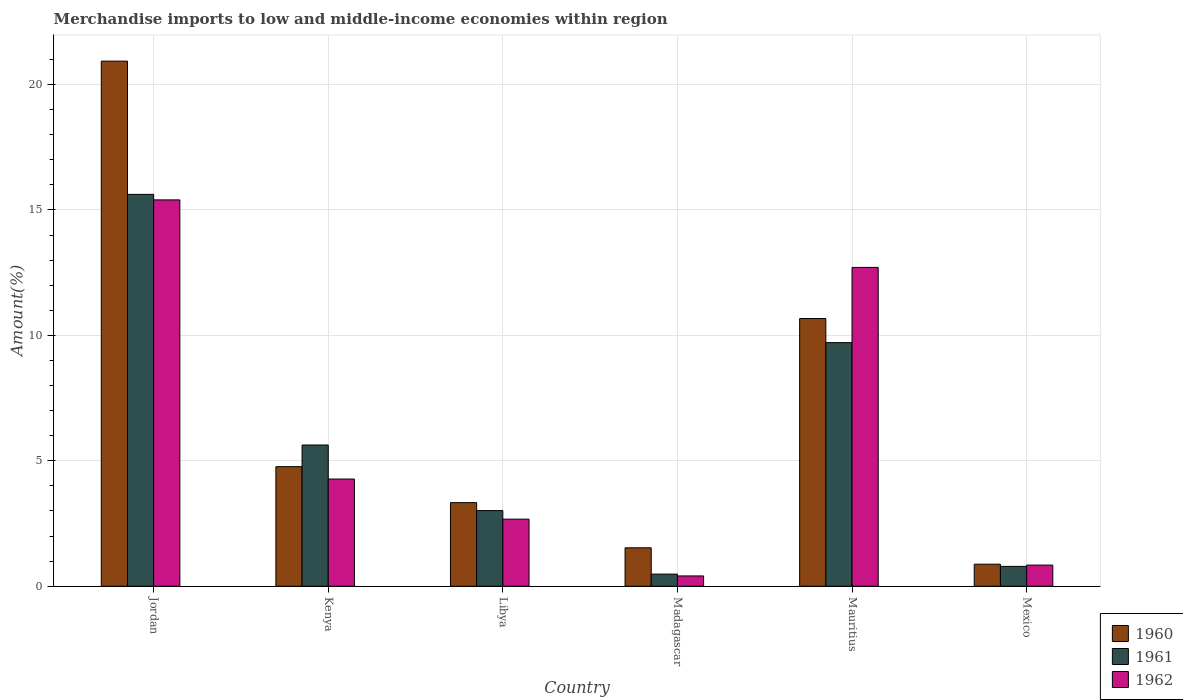How many different coloured bars are there?
Ensure brevity in your answer.  3. How many bars are there on the 5th tick from the left?
Offer a terse response. 3. How many bars are there on the 5th tick from the right?
Your answer should be compact. 3. What is the percentage of amount earned from merchandise imports in 1960 in Mexico?
Your answer should be very brief. 0.88. Across all countries, what is the maximum percentage of amount earned from merchandise imports in 1960?
Offer a very short reply. 20.93. Across all countries, what is the minimum percentage of amount earned from merchandise imports in 1960?
Make the answer very short. 0.88. In which country was the percentage of amount earned from merchandise imports in 1961 maximum?
Provide a short and direct response. Jordan. In which country was the percentage of amount earned from merchandise imports in 1961 minimum?
Ensure brevity in your answer.  Madagascar. What is the total percentage of amount earned from merchandise imports in 1960 in the graph?
Give a very brief answer. 42.12. What is the difference between the percentage of amount earned from merchandise imports in 1962 in Mauritius and that in Mexico?
Keep it short and to the point. 11.87. What is the difference between the percentage of amount earned from merchandise imports in 1961 in Libya and the percentage of amount earned from merchandise imports in 1962 in Mauritius?
Provide a succinct answer. -9.69. What is the average percentage of amount earned from merchandise imports in 1962 per country?
Offer a very short reply. 6.05. What is the difference between the percentage of amount earned from merchandise imports of/in 1962 and percentage of amount earned from merchandise imports of/in 1960 in Mauritius?
Your answer should be compact. 2.04. What is the ratio of the percentage of amount earned from merchandise imports in 1960 in Libya to that in Madagascar?
Your answer should be compact. 2.17. Is the difference between the percentage of amount earned from merchandise imports in 1962 in Kenya and Mauritius greater than the difference between the percentage of amount earned from merchandise imports in 1960 in Kenya and Mauritius?
Provide a succinct answer. No. What is the difference between the highest and the second highest percentage of amount earned from merchandise imports in 1961?
Provide a succinct answer. 4.08. What is the difference between the highest and the lowest percentage of amount earned from merchandise imports in 1962?
Your response must be concise. 14.99. In how many countries, is the percentage of amount earned from merchandise imports in 1961 greater than the average percentage of amount earned from merchandise imports in 1961 taken over all countries?
Your response must be concise. 2. What does the 2nd bar from the right in Madagascar represents?
Offer a very short reply. 1961. Is it the case that in every country, the sum of the percentage of amount earned from merchandise imports in 1961 and percentage of amount earned from merchandise imports in 1962 is greater than the percentage of amount earned from merchandise imports in 1960?
Your answer should be very brief. No. How many countries are there in the graph?
Offer a terse response. 6. Are the values on the major ticks of Y-axis written in scientific E-notation?
Keep it short and to the point. No. Does the graph contain any zero values?
Offer a very short reply. No. What is the title of the graph?
Offer a very short reply. Merchandise imports to low and middle-income economies within region. Does "1964" appear as one of the legend labels in the graph?
Ensure brevity in your answer.  No. What is the label or title of the Y-axis?
Keep it short and to the point. Amount(%). What is the Amount(%) in 1960 in Jordan?
Your answer should be compact. 20.93. What is the Amount(%) in 1961 in Jordan?
Provide a short and direct response. 15.62. What is the Amount(%) in 1962 in Jordan?
Make the answer very short. 15.4. What is the Amount(%) in 1960 in Kenya?
Ensure brevity in your answer.  4.77. What is the Amount(%) of 1961 in Kenya?
Provide a succinct answer. 5.63. What is the Amount(%) of 1962 in Kenya?
Your answer should be very brief. 4.27. What is the Amount(%) in 1960 in Libya?
Provide a succinct answer. 3.33. What is the Amount(%) in 1961 in Libya?
Your response must be concise. 3.02. What is the Amount(%) of 1962 in Libya?
Your response must be concise. 2.68. What is the Amount(%) in 1960 in Madagascar?
Your answer should be compact. 1.53. What is the Amount(%) in 1961 in Madagascar?
Give a very brief answer. 0.48. What is the Amount(%) in 1962 in Madagascar?
Keep it short and to the point. 0.41. What is the Amount(%) of 1960 in Mauritius?
Provide a succinct answer. 10.67. What is the Amount(%) of 1961 in Mauritius?
Make the answer very short. 9.71. What is the Amount(%) in 1962 in Mauritius?
Your answer should be very brief. 12.71. What is the Amount(%) of 1960 in Mexico?
Your answer should be compact. 0.88. What is the Amount(%) in 1961 in Mexico?
Your response must be concise. 0.79. What is the Amount(%) of 1962 in Mexico?
Your response must be concise. 0.84. Across all countries, what is the maximum Amount(%) of 1960?
Your answer should be very brief. 20.93. Across all countries, what is the maximum Amount(%) of 1961?
Your response must be concise. 15.62. Across all countries, what is the maximum Amount(%) of 1962?
Make the answer very short. 15.4. Across all countries, what is the minimum Amount(%) of 1960?
Make the answer very short. 0.88. Across all countries, what is the minimum Amount(%) of 1961?
Ensure brevity in your answer.  0.48. Across all countries, what is the minimum Amount(%) in 1962?
Give a very brief answer. 0.41. What is the total Amount(%) of 1960 in the graph?
Keep it short and to the point. 42.12. What is the total Amount(%) of 1961 in the graph?
Offer a terse response. 35.26. What is the total Amount(%) in 1962 in the graph?
Make the answer very short. 36.32. What is the difference between the Amount(%) in 1960 in Jordan and that in Kenya?
Your answer should be compact. 16.17. What is the difference between the Amount(%) of 1961 in Jordan and that in Kenya?
Provide a succinct answer. 9.99. What is the difference between the Amount(%) of 1962 in Jordan and that in Kenya?
Your response must be concise. 11.13. What is the difference between the Amount(%) of 1960 in Jordan and that in Libya?
Your answer should be very brief. 17.6. What is the difference between the Amount(%) in 1961 in Jordan and that in Libya?
Offer a terse response. 12.61. What is the difference between the Amount(%) of 1962 in Jordan and that in Libya?
Ensure brevity in your answer.  12.73. What is the difference between the Amount(%) in 1960 in Jordan and that in Madagascar?
Keep it short and to the point. 19.4. What is the difference between the Amount(%) in 1961 in Jordan and that in Madagascar?
Provide a short and direct response. 15.14. What is the difference between the Amount(%) of 1962 in Jordan and that in Madagascar?
Your response must be concise. 14.99. What is the difference between the Amount(%) in 1960 in Jordan and that in Mauritius?
Provide a short and direct response. 10.26. What is the difference between the Amount(%) of 1961 in Jordan and that in Mauritius?
Make the answer very short. 5.91. What is the difference between the Amount(%) of 1962 in Jordan and that in Mauritius?
Provide a short and direct response. 2.69. What is the difference between the Amount(%) of 1960 in Jordan and that in Mexico?
Make the answer very short. 20.06. What is the difference between the Amount(%) of 1961 in Jordan and that in Mexico?
Your answer should be compact. 14.83. What is the difference between the Amount(%) in 1962 in Jordan and that in Mexico?
Offer a very short reply. 14.56. What is the difference between the Amount(%) in 1960 in Kenya and that in Libya?
Give a very brief answer. 1.43. What is the difference between the Amount(%) in 1961 in Kenya and that in Libya?
Ensure brevity in your answer.  2.61. What is the difference between the Amount(%) of 1962 in Kenya and that in Libya?
Provide a short and direct response. 1.6. What is the difference between the Amount(%) of 1960 in Kenya and that in Madagascar?
Your answer should be compact. 3.23. What is the difference between the Amount(%) in 1961 in Kenya and that in Madagascar?
Your answer should be very brief. 5.15. What is the difference between the Amount(%) in 1962 in Kenya and that in Madagascar?
Offer a very short reply. 3.86. What is the difference between the Amount(%) of 1960 in Kenya and that in Mauritius?
Give a very brief answer. -5.9. What is the difference between the Amount(%) of 1961 in Kenya and that in Mauritius?
Keep it short and to the point. -4.08. What is the difference between the Amount(%) of 1962 in Kenya and that in Mauritius?
Your answer should be very brief. -8.44. What is the difference between the Amount(%) in 1960 in Kenya and that in Mexico?
Your answer should be compact. 3.89. What is the difference between the Amount(%) in 1961 in Kenya and that in Mexico?
Make the answer very short. 4.84. What is the difference between the Amount(%) in 1962 in Kenya and that in Mexico?
Make the answer very short. 3.43. What is the difference between the Amount(%) of 1960 in Libya and that in Madagascar?
Provide a succinct answer. 1.8. What is the difference between the Amount(%) of 1961 in Libya and that in Madagascar?
Keep it short and to the point. 2.53. What is the difference between the Amount(%) in 1962 in Libya and that in Madagascar?
Offer a very short reply. 2.26. What is the difference between the Amount(%) of 1960 in Libya and that in Mauritius?
Provide a succinct answer. -7.34. What is the difference between the Amount(%) in 1961 in Libya and that in Mauritius?
Offer a very short reply. -6.7. What is the difference between the Amount(%) of 1962 in Libya and that in Mauritius?
Keep it short and to the point. -10.04. What is the difference between the Amount(%) in 1960 in Libya and that in Mexico?
Offer a very short reply. 2.45. What is the difference between the Amount(%) in 1961 in Libya and that in Mexico?
Give a very brief answer. 2.22. What is the difference between the Amount(%) of 1962 in Libya and that in Mexico?
Your response must be concise. 1.83. What is the difference between the Amount(%) in 1960 in Madagascar and that in Mauritius?
Offer a terse response. -9.14. What is the difference between the Amount(%) in 1961 in Madagascar and that in Mauritius?
Offer a terse response. -9.23. What is the difference between the Amount(%) in 1962 in Madagascar and that in Mauritius?
Give a very brief answer. -12.3. What is the difference between the Amount(%) in 1960 in Madagascar and that in Mexico?
Your answer should be compact. 0.65. What is the difference between the Amount(%) of 1961 in Madagascar and that in Mexico?
Provide a short and direct response. -0.31. What is the difference between the Amount(%) in 1962 in Madagascar and that in Mexico?
Offer a very short reply. -0.43. What is the difference between the Amount(%) in 1960 in Mauritius and that in Mexico?
Your answer should be very brief. 9.79. What is the difference between the Amount(%) of 1961 in Mauritius and that in Mexico?
Provide a short and direct response. 8.92. What is the difference between the Amount(%) of 1962 in Mauritius and that in Mexico?
Your response must be concise. 11.87. What is the difference between the Amount(%) of 1960 in Jordan and the Amount(%) of 1961 in Kenya?
Provide a short and direct response. 15.3. What is the difference between the Amount(%) in 1960 in Jordan and the Amount(%) in 1962 in Kenya?
Offer a very short reply. 16.66. What is the difference between the Amount(%) of 1961 in Jordan and the Amount(%) of 1962 in Kenya?
Keep it short and to the point. 11.35. What is the difference between the Amount(%) in 1960 in Jordan and the Amount(%) in 1961 in Libya?
Provide a short and direct response. 17.92. What is the difference between the Amount(%) of 1960 in Jordan and the Amount(%) of 1962 in Libya?
Provide a succinct answer. 18.26. What is the difference between the Amount(%) of 1961 in Jordan and the Amount(%) of 1962 in Libya?
Ensure brevity in your answer.  12.95. What is the difference between the Amount(%) in 1960 in Jordan and the Amount(%) in 1961 in Madagascar?
Give a very brief answer. 20.45. What is the difference between the Amount(%) of 1960 in Jordan and the Amount(%) of 1962 in Madagascar?
Offer a terse response. 20.52. What is the difference between the Amount(%) in 1961 in Jordan and the Amount(%) in 1962 in Madagascar?
Provide a short and direct response. 15.21. What is the difference between the Amount(%) of 1960 in Jordan and the Amount(%) of 1961 in Mauritius?
Give a very brief answer. 11.22. What is the difference between the Amount(%) of 1960 in Jordan and the Amount(%) of 1962 in Mauritius?
Offer a very short reply. 8.22. What is the difference between the Amount(%) of 1961 in Jordan and the Amount(%) of 1962 in Mauritius?
Keep it short and to the point. 2.91. What is the difference between the Amount(%) in 1960 in Jordan and the Amount(%) in 1961 in Mexico?
Make the answer very short. 20.14. What is the difference between the Amount(%) of 1960 in Jordan and the Amount(%) of 1962 in Mexico?
Ensure brevity in your answer.  20.09. What is the difference between the Amount(%) of 1961 in Jordan and the Amount(%) of 1962 in Mexico?
Your response must be concise. 14.78. What is the difference between the Amount(%) in 1960 in Kenya and the Amount(%) in 1961 in Libya?
Ensure brevity in your answer.  1.75. What is the difference between the Amount(%) of 1960 in Kenya and the Amount(%) of 1962 in Libya?
Keep it short and to the point. 2.09. What is the difference between the Amount(%) in 1961 in Kenya and the Amount(%) in 1962 in Libya?
Your response must be concise. 2.96. What is the difference between the Amount(%) of 1960 in Kenya and the Amount(%) of 1961 in Madagascar?
Your answer should be very brief. 4.28. What is the difference between the Amount(%) in 1960 in Kenya and the Amount(%) in 1962 in Madagascar?
Keep it short and to the point. 4.36. What is the difference between the Amount(%) of 1961 in Kenya and the Amount(%) of 1962 in Madagascar?
Keep it short and to the point. 5.22. What is the difference between the Amount(%) of 1960 in Kenya and the Amount(%) of 1961 in Mauritius?
Provide a short and direct response. -4.94. What is the difference between the Amount(%) of 1960 in Kenya and the Amount(%) of 1962 in Mauritius?
Provide a succinct answer. -7.94. What is the difference between the Amount(%) in 1961 in Kenya and the Amount(%) in 1962 in Mauritius?
Make the answer very short. -7.08. What is the difference between the Amount(%) of 1960 in Kenya and the Amount(%) of 1961 in Mexico?
Your response must be concise. 3.98. What is the difference between the Amount(%) of 1960 in Kenya and the Amount(%) of 1962 in Mexico?
Ensure brevity in your answer.  3.92. What is the difference between the Amount(%) of 1961 in Kenya and the Amount(%) of 1962 in Mexico?
Your answer should be compact. 4.79. What is the difference between the Amount(%) of 1960 in Libya and the Amount(%) of 1961 in Madagascar?
Offer a terse response. 2.85. What is the difference between the Amount(%) in 1960 in Libya and the Amount(%) in 1962 in Madagascar?
Provide a succinct answer. 2.92. What is the difference between the Amount(%) in 1961 in Libya and the Amount(%) in 1962 in Madagascar?
Provide a succinct answer. 2.6. What is the difference between the Amount(%) in 1960 in Libya and the Amount(%) in 1961 in Mauritius?
Keep it short and to the point. -6.38. What is the difference between the Amount(%) of 1960 in Libya and the Amount(%) of 1962 in Mauritius?
Your answer should be compact. -9.38. What is the difference between the Amount(%) of 1961 in Libya and the Amount(%) of 1962 in Mauritius?
Give a very brief answer. -9.69. What is the difference between the Amount(%) in 1960 in Libya and the Amount(%) in 1961 in Mexico?
Your answer should be compact. 2.54. What is the difference between the Amount(%) of 1960 in Libya and the Amount(%) of 1962 in Mexico?
Your response must be concise. 2.49. What is the difference between the Amount(%) in 1961 in Libya and the Amount(%) in 1962 in Mexico?
Your answer should be compact. 2.17. What is the difference between the Amount(%) of 1960 in Madagascar and the Amount(%) of 1961 in Mauritius?
Ensure brevity in your answer.  -8.18. What is the difference between the Amount(%) of 1960 in Madagascar and the Amount(%) of 1962 in Mauritius?
Your answer should be very brief. -11.18. What is the difference between the Amount(%) of 1961 in Madagascar and the Amount(%) of 1962 in Mauritius?
Offer a very short reply. -12.23. What is the difference between the Amount(%) of 1960 in Madagascar and the Amount(%) of 1961 in Mexico?
Ensure brevity in your answer.  0.74. What is the difference between the Amount(%) of 1960 in Madagascar and the Amount(%) of 1962 in Mexico?
Keep it short and to the point. 0.69. What is the difference between the Amount(%) of 1961 in Madagascar and the Amount(%) of 1962 in Mexico?
Provide a short and direct response. -0.36. What is the difference between the Amount(%) of 1960 in Mauritius and the Amount(%) of 1961 in Mexico?
Ensure brevity in your answer.  9.88. What is the difference between the Amount(%) in 1960 in Mauritius and the Amount(%) in 1962 in Mexico?
Provide a short and direct response. 9.83. What is the difference between the Amount(%) in 1961 in Mauritius and the Amount(%) in 1962 in Mexico?
Ensure brevity in your answer.  8.87. What is the average Amount(%) in 1960 per country?
Your answer should be compact. 7.02. What is the average Amount(%) of 1961 per country?
Your response must be concise. 5.88. What is the average Amount(%) in 1962 per country?
Your answer should be compact. 6.05. What is the difference between the Amount(%) in 1960 and Amount(%) in 1961 in Jordan?
Keep it short and to the point. 5.31. What is the difference between the Amount(%) of 1960 and Amount(%) of 1962 in Jordan?
Offer a very short reply. 5.53. What is the difference between the Amount(%) of 1961 and Amount(%) of 1962 in Jordan?
Ensure brevity in your answer.  0.22. What is the difference between the Amount(%) of 1960 and Amount(%) of 1961 in Kenya?
Your answer should be compact. -0.86. What is the difference between the Amount(%) of 1960 and Amount(%) of 1962 in Kenya?
Give a very brief answer. 0.49. What is the difference between the Amount(%) in 1961 and Amount(%) in 1962 in Kenya?
Offer a terse response. 1.36. What is the difference between the Amount(%) of 1960 and Amount(%) of 1961 in Libya?
Provide a short and direct response. 0.32. What is the difference between the Amount(%) in 1960 and Amount(%) in 1962 in Libya?
Give a very brief answer. 0.66. What is the difference between the Amount(%) in 1961 and Amount(%) in 1962 in Libya?
Provide a succinct answer. 0.34. What is the difference between the Amount(%) of 1960 and Amount(%) of 1961 in Madagascar?
Give a very brief answer. 1.05. What is the difference between the Amount(%) in 1960 and Amount(%) in 1962 in Madagascar?
Ensure brevity in your answer.  1.12. What is the difference between the Amount(%) in 1961 and Amount(%) in 1962 in Madagascar?
Provide a short and direct response. 0.07. What is the difference between the Amount(%) of 1960 and Amount(%) of 1961 in Mauritius?
Make the answer very short. 0.96. What is the difference between the Amount(%) of 1960 and Amount(%) of 1962 in Mauritius?
Offer a very short reply. -2.04. What is the difference between the Amount(%) in 1961 and Amount(%) in 1962 in Mauritius?
Ensure brevity in your answer.  -3. What is the difference between the Amount(%) in 1960 and Amount(%) in 1961 in Mexico?
Provide a succinct answer. 0.09. What is the difference between the Amount(%) of 1960 and Amount(%) of 1962 in Mexico?
Your answer should be very brief. 0.04. What is the difference between the Amount(%) in 1961 and Amount(%) in 1962 in Mexico?
Your answer should be very brief. -0.05. What is the ratio of the Amount(%) in 1960 in Jordan to that in Kenya?
Offer a terse response. 4.39. What is the ratio of the Amount(%) in 1961 in Jordan to that in Kenya?
Ensure brevity in your answer.  2.77. What is the ratio of the Amount(%) in 1962 in Jordan to that in Kenya?
Give a very brief answer. 3.6. What is the ratio of the Amount(%) in 1960 in Jordan to that in Libya?
Make the answer very short. 6.28. What is the ratio of the Amount(%) of 1961 in Jordan to that in Libya?
Provide a short and direct response. 5.18. What is the ratio of the Amount(%) of 1962 in Jordan to that in Libya?
Your answer should be very brief. 5.76. What is the ratio of the Amount(%) in 1960 in Jordan to that in Madagascar?
Keep it short and to the point. 13.66. What is the ratio of the Amount(%) in 1961 in Jordan to that in Madagascar?
Your answer should be very brief. 32.24. What is the ratio of the Amount(%) of 1962 in Jordan to that in Madagascar?
Your answer should be very brief. 37.46. What is the ratio of the Amount(%) in 1960 in Jordan to that in Mauritius?
Offer a terse response. 1.96. What is the ratio of the Amount(%) of 1961 in Jordan to that in Mauritius?
Make the answer very short. 1.61. What is the ratio of the Amount(%) in 1962 in Jordan to that in Mauritius?
Make the answer very short. 1.21. What is the ratio of the Amount(%) of 1960 in Jordan to that in Mexico?
Make the answer very short. 23.81. What is the ratio of the Amount(%) in 1961 in Jordan to that in Mexico?
Ensure brevity in your answer.  19.72. What is the ratio of the Amount(%) in 1962 in Jordan to that in Mexico?
Give a very brief answer. 18.27. What is the ratio of the Amount(%) of 1960 in Kenya to that in Libya?
Ensure brevity in your answer.  1.43. What is the ratio of the Amount(%) of 1961 in Kenya to that in Libya?
Make the answer very short. 1.87. What is the ratio of the Amount(%) in 1962 in Kenya to that in Libya?
Your response must be concise. 1.6. What is the ratio of the Amount(%) of 1960 in Kenya to that in Madagascar?
Provide a succinct answer. 3.11. What is the ratio of the Amount(%) in 1961 in Kenya to that in Madagascar?
Offer a terse response. 11.62. What is the ratio of the Amount(%) in 1962 in Kenya to that in Madagascar?
Your answer should be compact. 10.39. What is the ratio of the Amount(%) in 1960 in Kenya to that in Mauritius?
Your response must be concise. 0.45. What is the ratio of the Amount(%) of 1961 in Kenya to that in Mauritius?
Provide a short and direct response. 0.58. What is the ratio of the Amount(%) of 1962 in Kenya to that in Mauritius?
Keep it short and to the point. 0.34. What is the ratio of the Amount(%) in 1960 in Kenya to that in Mexico?
Provide a succinct answer. 5.42. What is the ratio of the Amount(%) of 1961 in Kenya to that in Mexico?
Provide a succinct answer. 7.11. What is the ratio of the Amount(%) in 1962 in Kenya to that in Mexico?
Provide a succinct answer. 5.07. What is the ratio of the Amount(%) in 1960 in Libya to that in Madagascar?
Offer a terse response. 2.17. What is the ratio of the Amount(%) in 1961 in Libya to that in Madagascar?
Make the answer very short. 6.23. What is the ratio of the Amount(%) in 1962 in Libya to that in Madagascar?
Your response must be concise. 6.51. What is the ratio of the Amount(%) in 1960 in Libya to that in Mauritius?
Provide a succinct answer. 0.31. What is the ratio of the Amount(%) in 1961 in Libya to that in Mauritius?
Your response must be concise. 0.31. What is the ratio of the Amount(%) in 1962 in Libya to that in Mauritius?
Offer a terse response. 0.21. What is the ratio of the Amount(%) in 1960 in Libya to that in Mexico?
Your response must be concise. 3.79. What is the ratio of the Amount(%) in 1961 in Libya to that in Mexico?
Provide a short and direct response. 3.81. What is the ratio of the Amount(%) in 1962 in Libya to that in Mexico?
Your answer should be very brief. 3.17. What is the ratio of the Amount(%) in 1960 in Madagascar to that in Mauritius?
Keep it short and to the point. 0.14. What is the ratio of the Amount(%) in 1961 in Madagascar to that in Mauritius?
Provide a short and direct response. 0.05. What is the ratio of the Amount(%) in 1962 in Madagascar to that in Mauritius?
Offer a terse response. 0.03. What is the ratio of the Amount(%) of 1960 in Madagascar to that in Mexico?
Provide a short and direct response. 1.74. What is the ratio of the Amount(%) of 1961 in Madagascar to that in Mexico?
Keep it short and to the point. 0.61. What is the ratio of the Amount(%) in 1962 in Madagascar to that in Mexico?
Ensure brevity in your answer.  0.49. What is the ratio of the Amount(%) in 1960 in Mauritius to that in Mexico?
Make the answer very short. 12.14. What is the ratio of the Amount(%) in 1961 in Mauritius to that in Mexico?
Offer a terse response. 12.26. What is the ratio of the Amount(%) in 1962 in Mauritius to that in Mexico?
Offer a very short reply. 15.08. What is the difference between the highest and the second highest Amount(%) in 1960?
Offer a very short reply. 10.26. What is the difference between the highest and the second highest Amount(%) of 1961?
Your response must be concise. 5.91. What is the difference between the highest and the second highest Amount(%) in 1962?
Your answer should be very brief. 2.69. What is the difference between the highest and the lowest Amount(%) of 1960?
Keep it short and to the point. 20.06. What is the difference between the highest and the lowest Amount(%) in 1961?
Provide a succinct answer. 15.14. What is the difference between the highest and the lowest Amount(%) of 1962?
Ensure brevity in your answer.  14.99. 